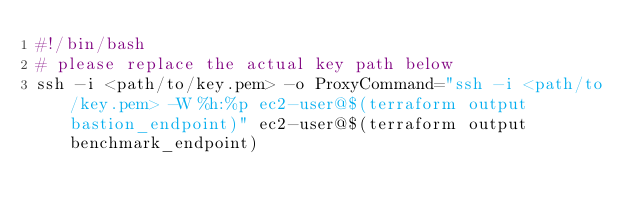Convert code to text. <code><loc_0><loc_0><loc_500><loc_500><_Bash_>#!/bin/bash
# please replace the actual key path below
ssh -i <path/to/key.pem> -o ProxyCommand="ssh -i <path/to/key.pem> -W %h:%p ec2-user@$(terraform output bastion_endpoint)" ec2-user@$(terraform output benchmark_endpoint)
</code> 